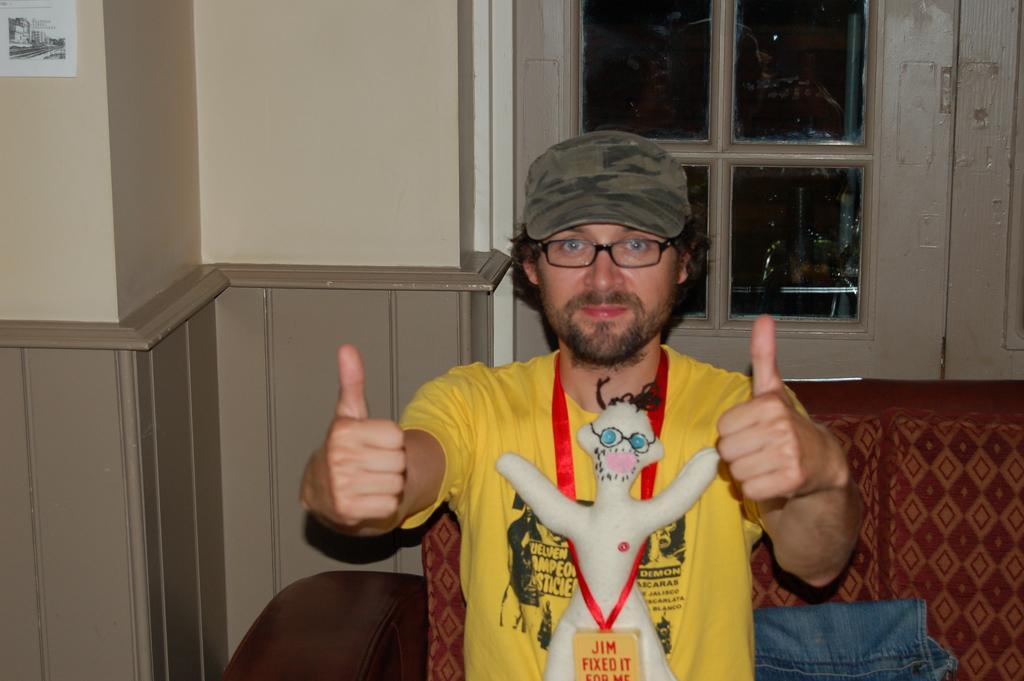Could you give a brief overview of what you see in this image? In this image in the center there is one person who is wearing a cap, and tail and he showing his thumb fingers. And in the background there is a couch, clothes, wall, window. And in the top left hand corner there is some poster on the wall. 